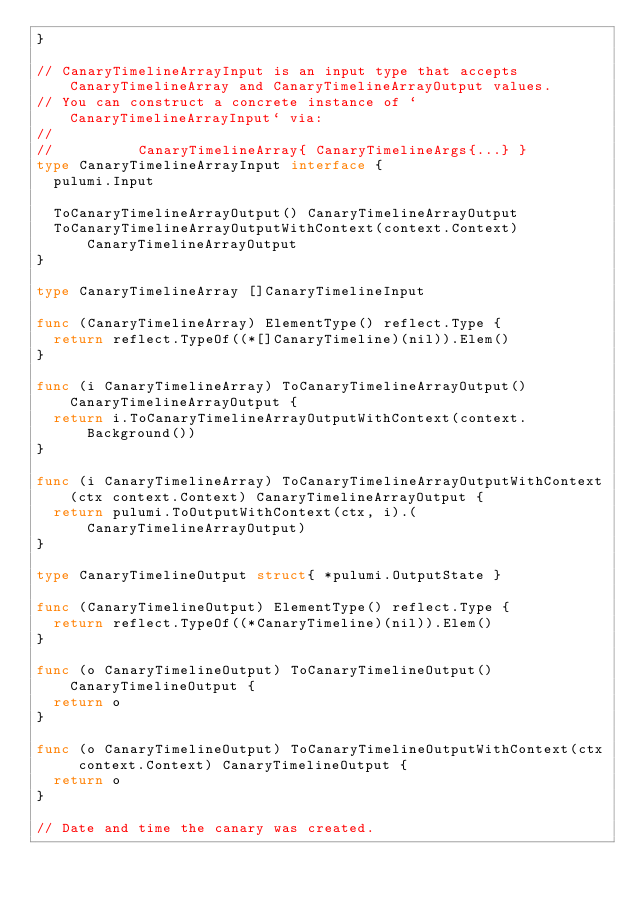Convert code to text. <code><loc_0><loc_0><loc_500><loc_500><_Go_>}

// CanaryTimelineArrayInput is an input type that accepts CanaryTimelineArray and CanaryTimelineArrayOutput values.
// You can construct a concrete instance of `CanaryTimelineArrayInput` via:
//
//          CanaryTimelineArray{ CanaryTimelineArgs{...} }
type CanaryTimelineArrayInput interface {
	pulumi.Input

	ToCanaryTimelineArrayOutput() CanaryTimelineArrayOutput
	ToCanaryTimelineArrayOutputWithContext(context.Context) CanaryTimelineArrayOutput
}

type CanaryTimelineArray []CanaryTimelineInput

func (CanaryTimelineArray) ElementType() reflect.Type {
	return reflect.TypeOf((*[]CanaryTimeline)(nil)).Elem()
}

func (i CanaryTimelineArray) ToCanaryTimelineArrayOutput() CanaryTimelineArrayOutput {
	return i.ToCanaryTimelineArrayOutputWithContext(context.Background())
}

func (i CanaryTimelineArray) ToCanaryTimelineArrayOutputWithContext(ctx context.Context) CanaryTimelineArrayOutput {
	return pulumi.ToOutputWithContext(ctx, i).(CanaryTimelineArrayOutput)
}

type CanaryTimelineOutput struct{ *pulumi.OutputState }

func (CanaryTimelineOutput) ElementType() reflect.Type {
	return reflect.TypeOf((*CanaryTimeline)(nil)).Elem()
}

func (o CanaryTimelineOutput) ToCanaryTimelineOutput() CanaryTimelineOutput {
	return o
}

func (o CanaryTimelineOutput) ToCanaryTimelineOutputWithContext(ctx context.Context) CanaryTimelineOutput {
	return o
}

// Date and time the canary was created.</code> 